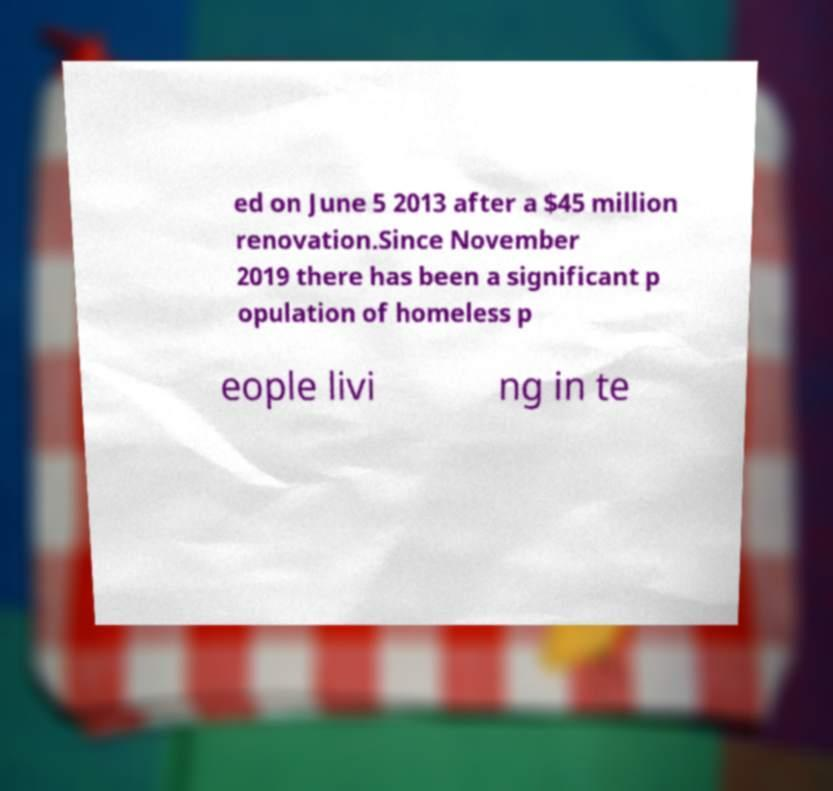There's text embedded in this image that I need extracted. Can you transcribe it verbatim? ed on June 5 2013 after a $45 million renovation.Since November 2019 there has been a significant p opulation of homeless p eople livi ng in te 